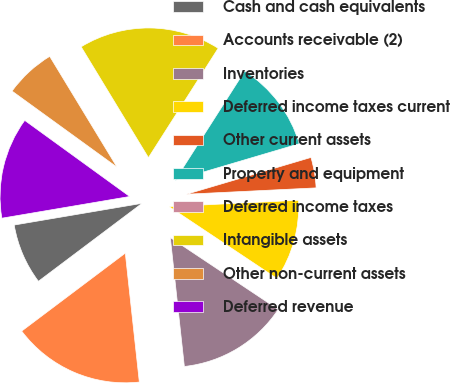Convert chart. <chart><loc_0><loc_0><loc_500><loc_500><pie_chart><fcel>Cash and cash equivalents<fcel>Accounts receivable (2)<fcel>Inventories<fcel>Deferred income taxes current<fcel>Other current assets<fcel>Property and equipment<fcel>Deferred income taxes<fcel>Intangible assets<fcel>Other non-current assets<fcel>Deferred revenue<nl><fcel>7.59%<fcel>16.46%<fcel>13.92%<fcel>10.13%<fcel>3.8%<fcel>11.39%<fcel>0.0%<fcel>17.72%<fcel>6.33%<fcel>12.66%<nl></chart> 